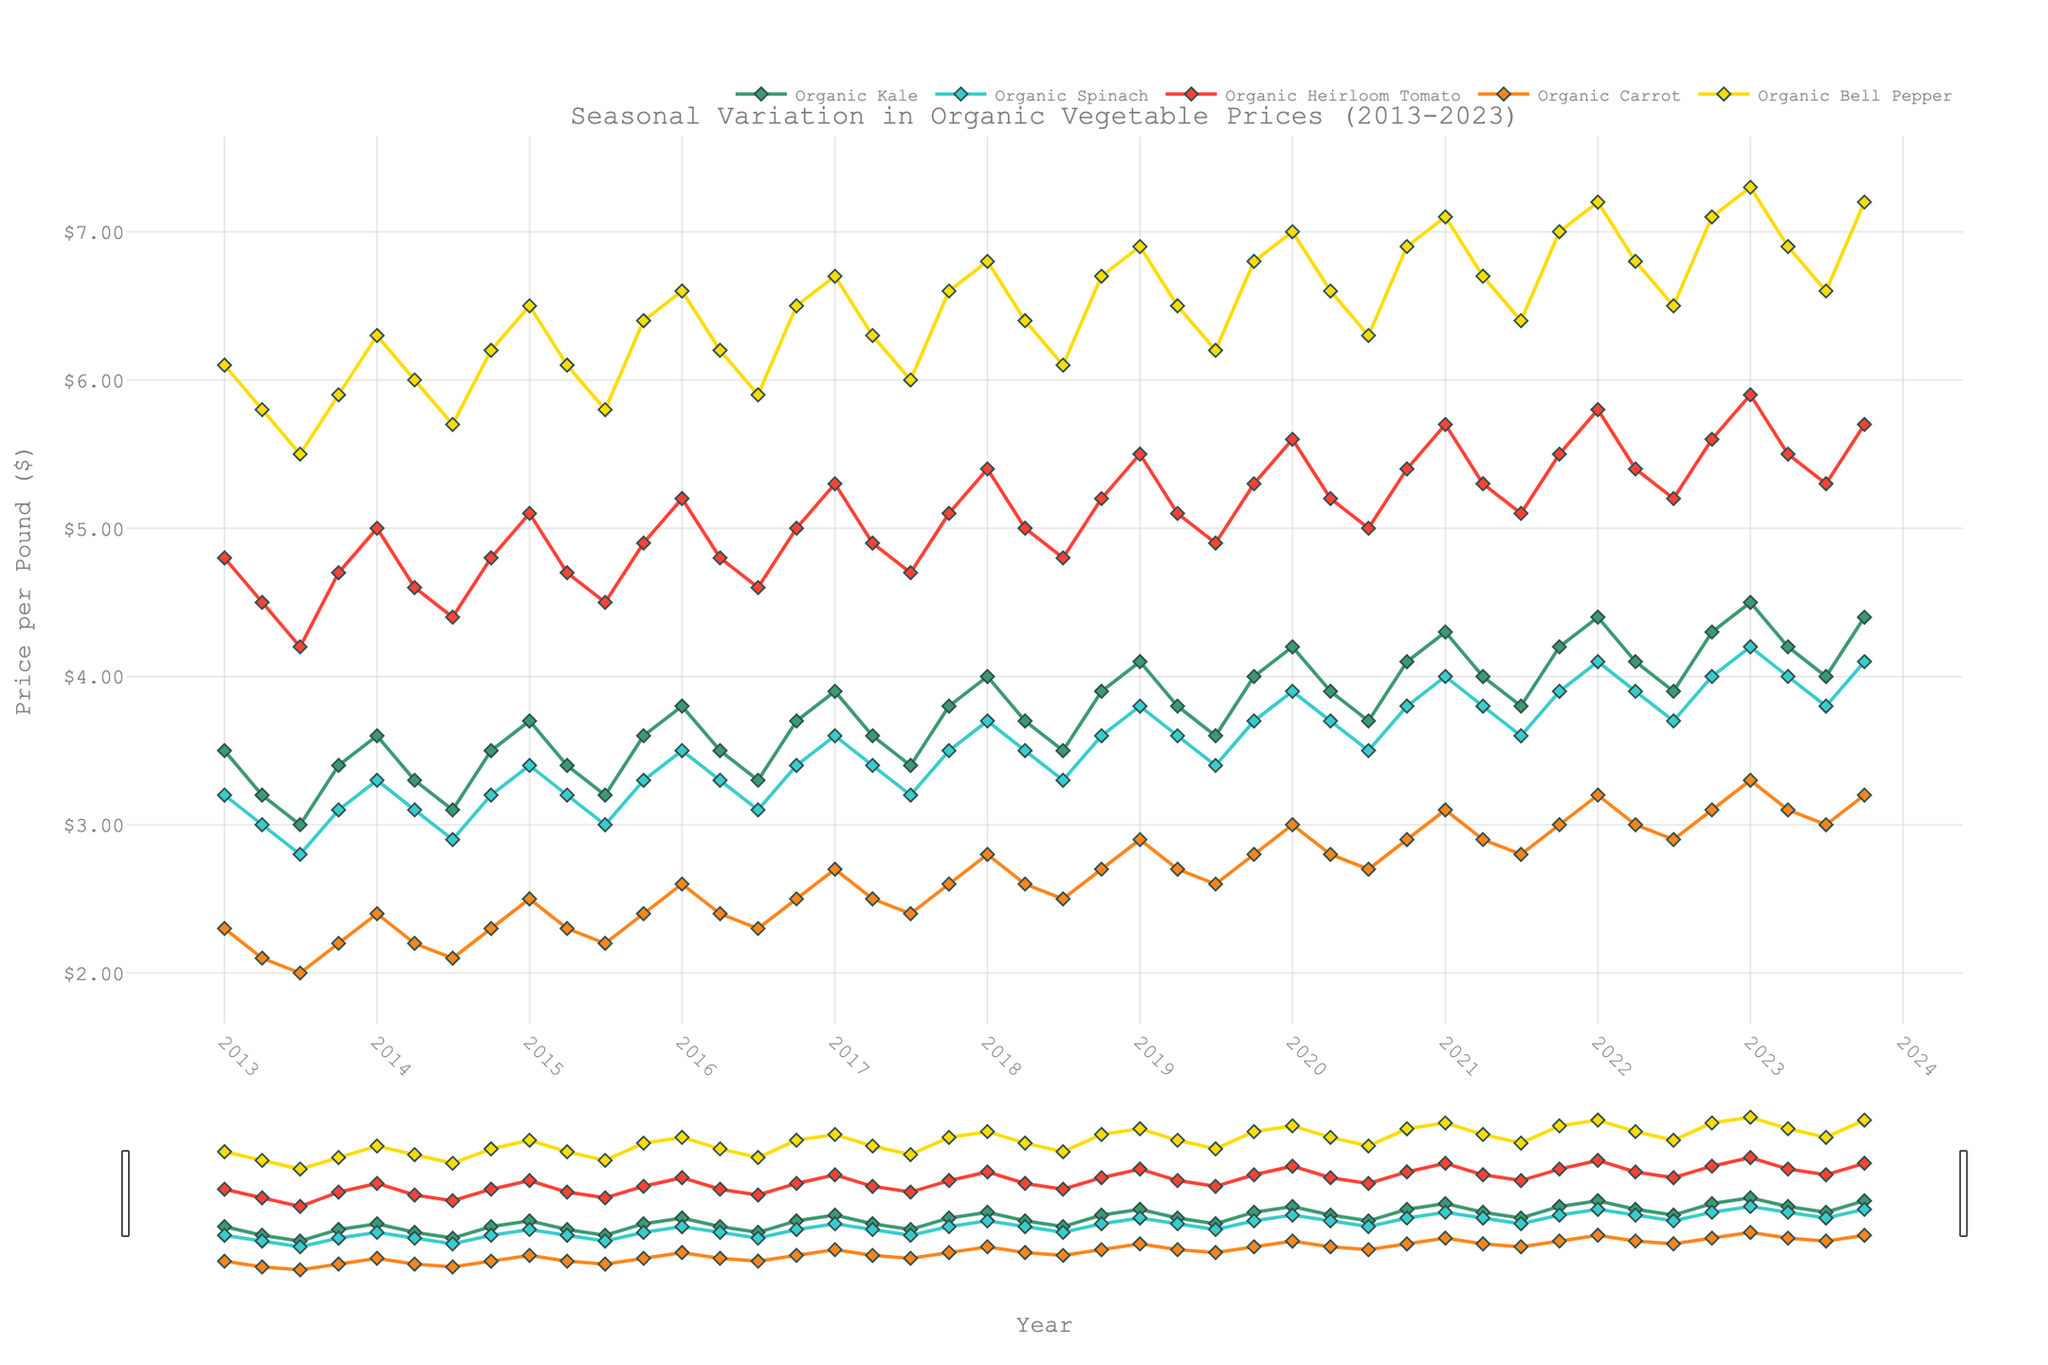What is the title of the plot? The title of the plot is displayed at the top and gives an overview of the content. The plot shows the seasonal variation in organic vegetable prices over a decade.
Answer: Seasonal Variation in Organic Vegetable Prices (2013-2023) Which organic vegetable experienced the highest price in January 2023? To find the highest price, look at the data points for January 2023. Compare the prices for Organic Kale, Spinach, Heirloom Tomato, Carrot, and Bell Pepper.
Answer: Organic Bell Pepper How did the price of Organic Kale change from January 2013 to January 2023? Look at the price data points for Organic Kale in January 2013 and January 2023. Calculate the difference. January 2013 price is $3.5, and January 2023 price is $4.5. The change is $4.5 - $3.5.
Answer: Increased by $1.0 In which month did Organic Carrot have the lowest price in any year? Scan the plot for the lowest data point for Organic Carrot. The lowest price appears in several months, join the dots and see the labels for the corresponding months.
Answer: July What is the average price of Organic Spinach over the four quarters of 2019? Extract the prices of Organic Spinach in January, April, July, and October of 2019. The prices are $3.8, $3.6, $3.4, and $3.7 respectively. The average is calculated as (3.8 + 3.6 + 3.4 + 3.7) / 4.
Answer: $3.625 Was there a continuous increase in the price of any organic vegetable over the entire period from 2013 to 2023? Examine each vegetable's trend line from 2013 to 2023. None of the vegetables show a strictly increasing trend each year over this period; there are fluctuations.
Answer: No Which organic vegetable shows the most pronounced seasonal variation (i.e., the largest differences within each year)? Compare the range of seasonal fluctuations for each vegetable over the years. Identify which one has the largest amplitude in price changes.
Answer: Organic Bell Pepper What year had the highest average price for Organic Heirloom Tomato? Find the average price for Organic Heirloom Tomato for each year by averaging the quarterly prices and then determine the year with the highest average.
Answer: 2021 By how much did the price of Organic Bell Pepper change from October 2020 to October 2021? Find the price of Organic Bell Pepper in October 2020 and October 2021. The prices are $6.9 and $7.0 respectively. The difference is $7.0 - $6.9.
Answer: $0.1 